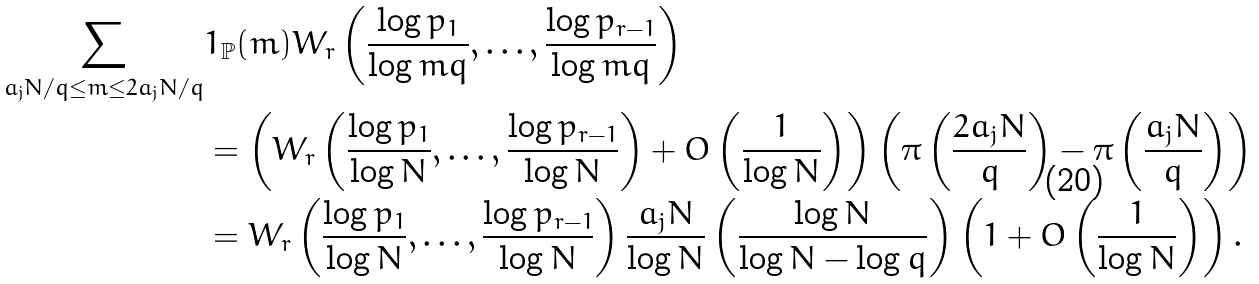Convert formula to latex. <formula><loc_0><loc_0><loc_500><loc_500>\sum _ { a _ { j } N / q \leq m \leq 2 a _ { j } N / q } & 1 _ { \mathbb { P } } ( m ) W _ { r } \left ( \frac { \log { p _ { 1 } } } { \log { m q } } , \dots , \frac { \log { p _ { r - 1 } } } { \log { m q } } \right ) \\ & = \left ( W _ { r } \left ( \frac { \log { p _ { 1 } } } { \log { N } } , \dots , \frac { \log { p _ { r - 1 } } } { \log { N } } \right ) + O \left ( \frac { 1 } { \log { N } } \right ) \right ) \left ( \pi \left ( \frac { 2 a _ { j } N } { q } \right ) - \pi \left ( \frac { a _ { j } N } { q } \right ) \right ) \\ & = W _ { r } \left ( \frac { \log { p _ { 1 } } } { \log { N } } , \dots , \frac { \log { p _ { r - 1 } } } { \log { N } } \right ) \frac { a _ { j } N } { \log { N } } \left ( \frac { \log { N } } { \log { N } - \log { q } } \right ) \left ( 1 + O \left ( \frac { 1 } { \log { N } } \right ) \right ) .</formula> 